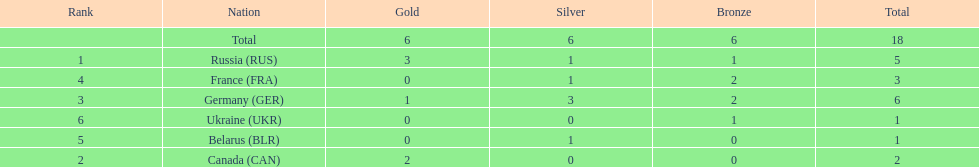What country only received gold medals in the 1994 winter olympics biathlon? Canada (CAN). 